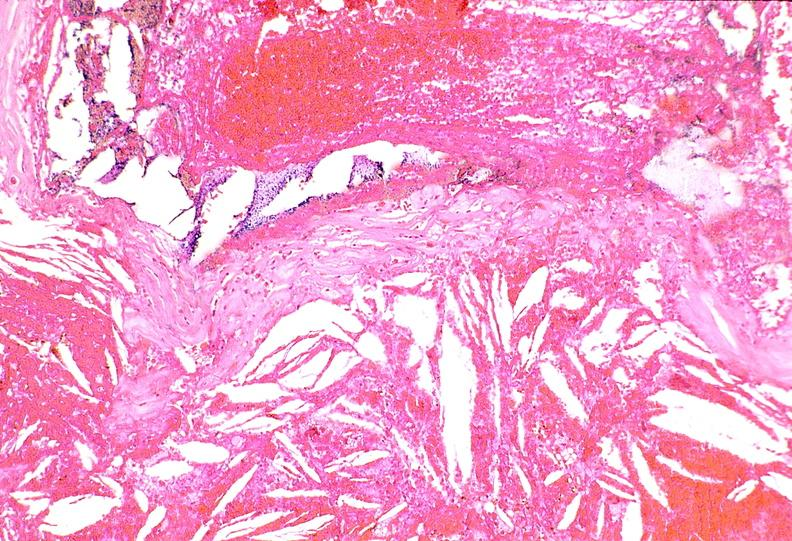s granulomata slide present?
Answer the question using a single word or phrase. No 